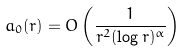Convert formula to latex. <formula><loc_0><loc_0><loc_500><loc_500>a _ { 0 } ( r ) = O \left ( \frac { 1 } { r ^ { 2 } ( \log r ) ^ { \alpha } } \right )</formula> 